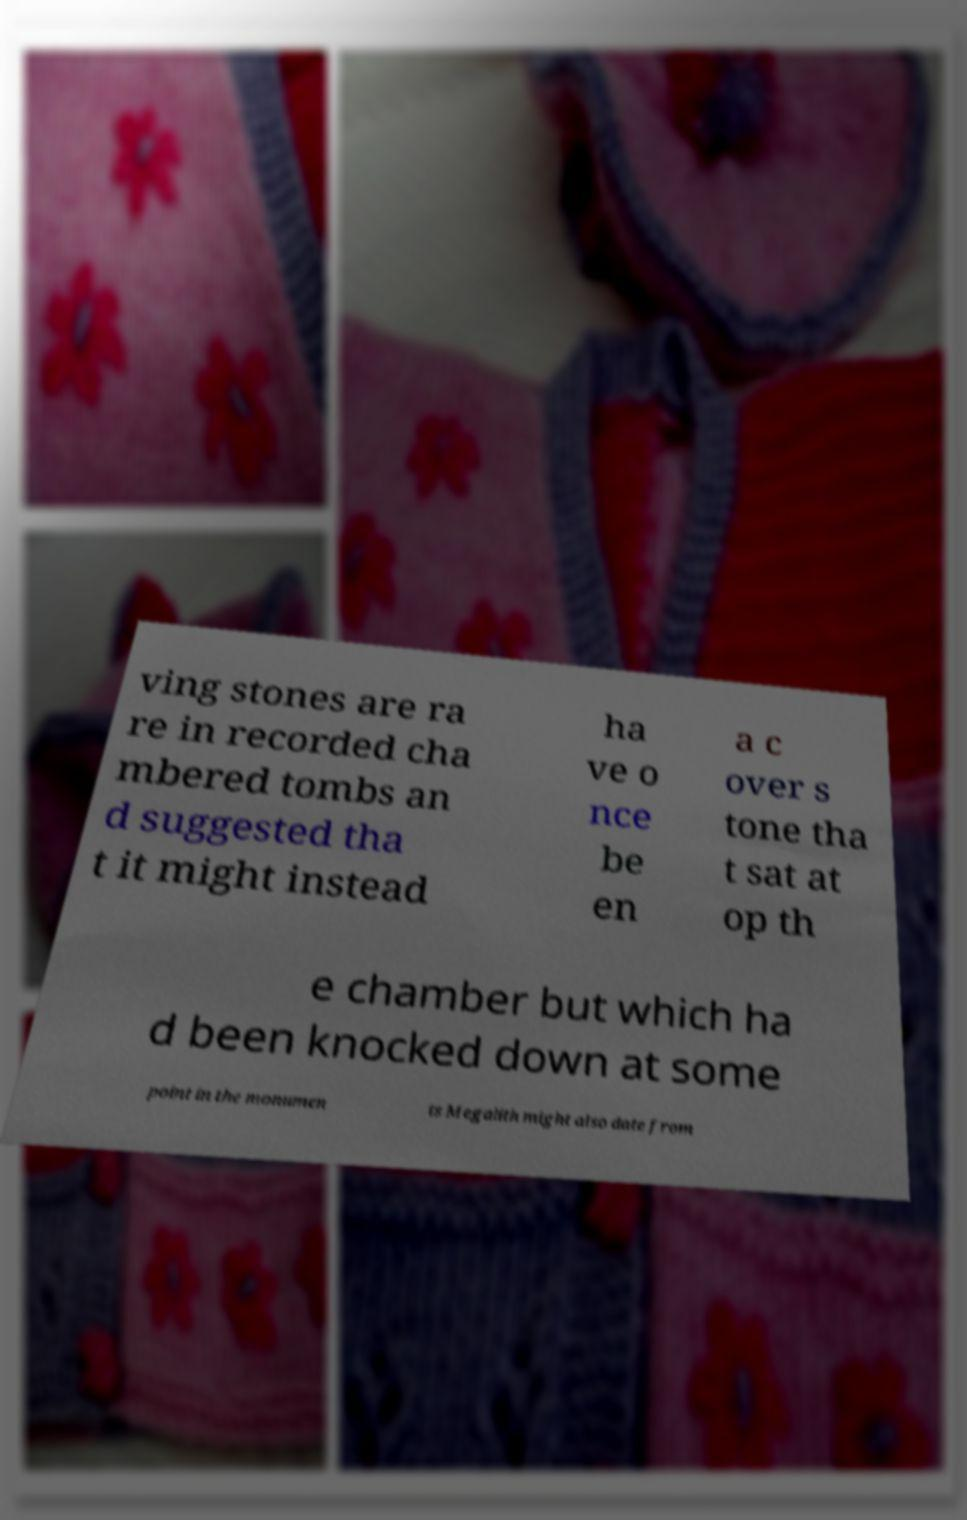Please read and relay the text visible in this image. What does it say? ving stones are ra re in recorded cha mbered tombs an d suggested tha t it might instead ha ve o nce be en a c over s tone tha t sat at op th e chamber but which ha d been knocked down at some point in the monumen ts Megalith might also date from 